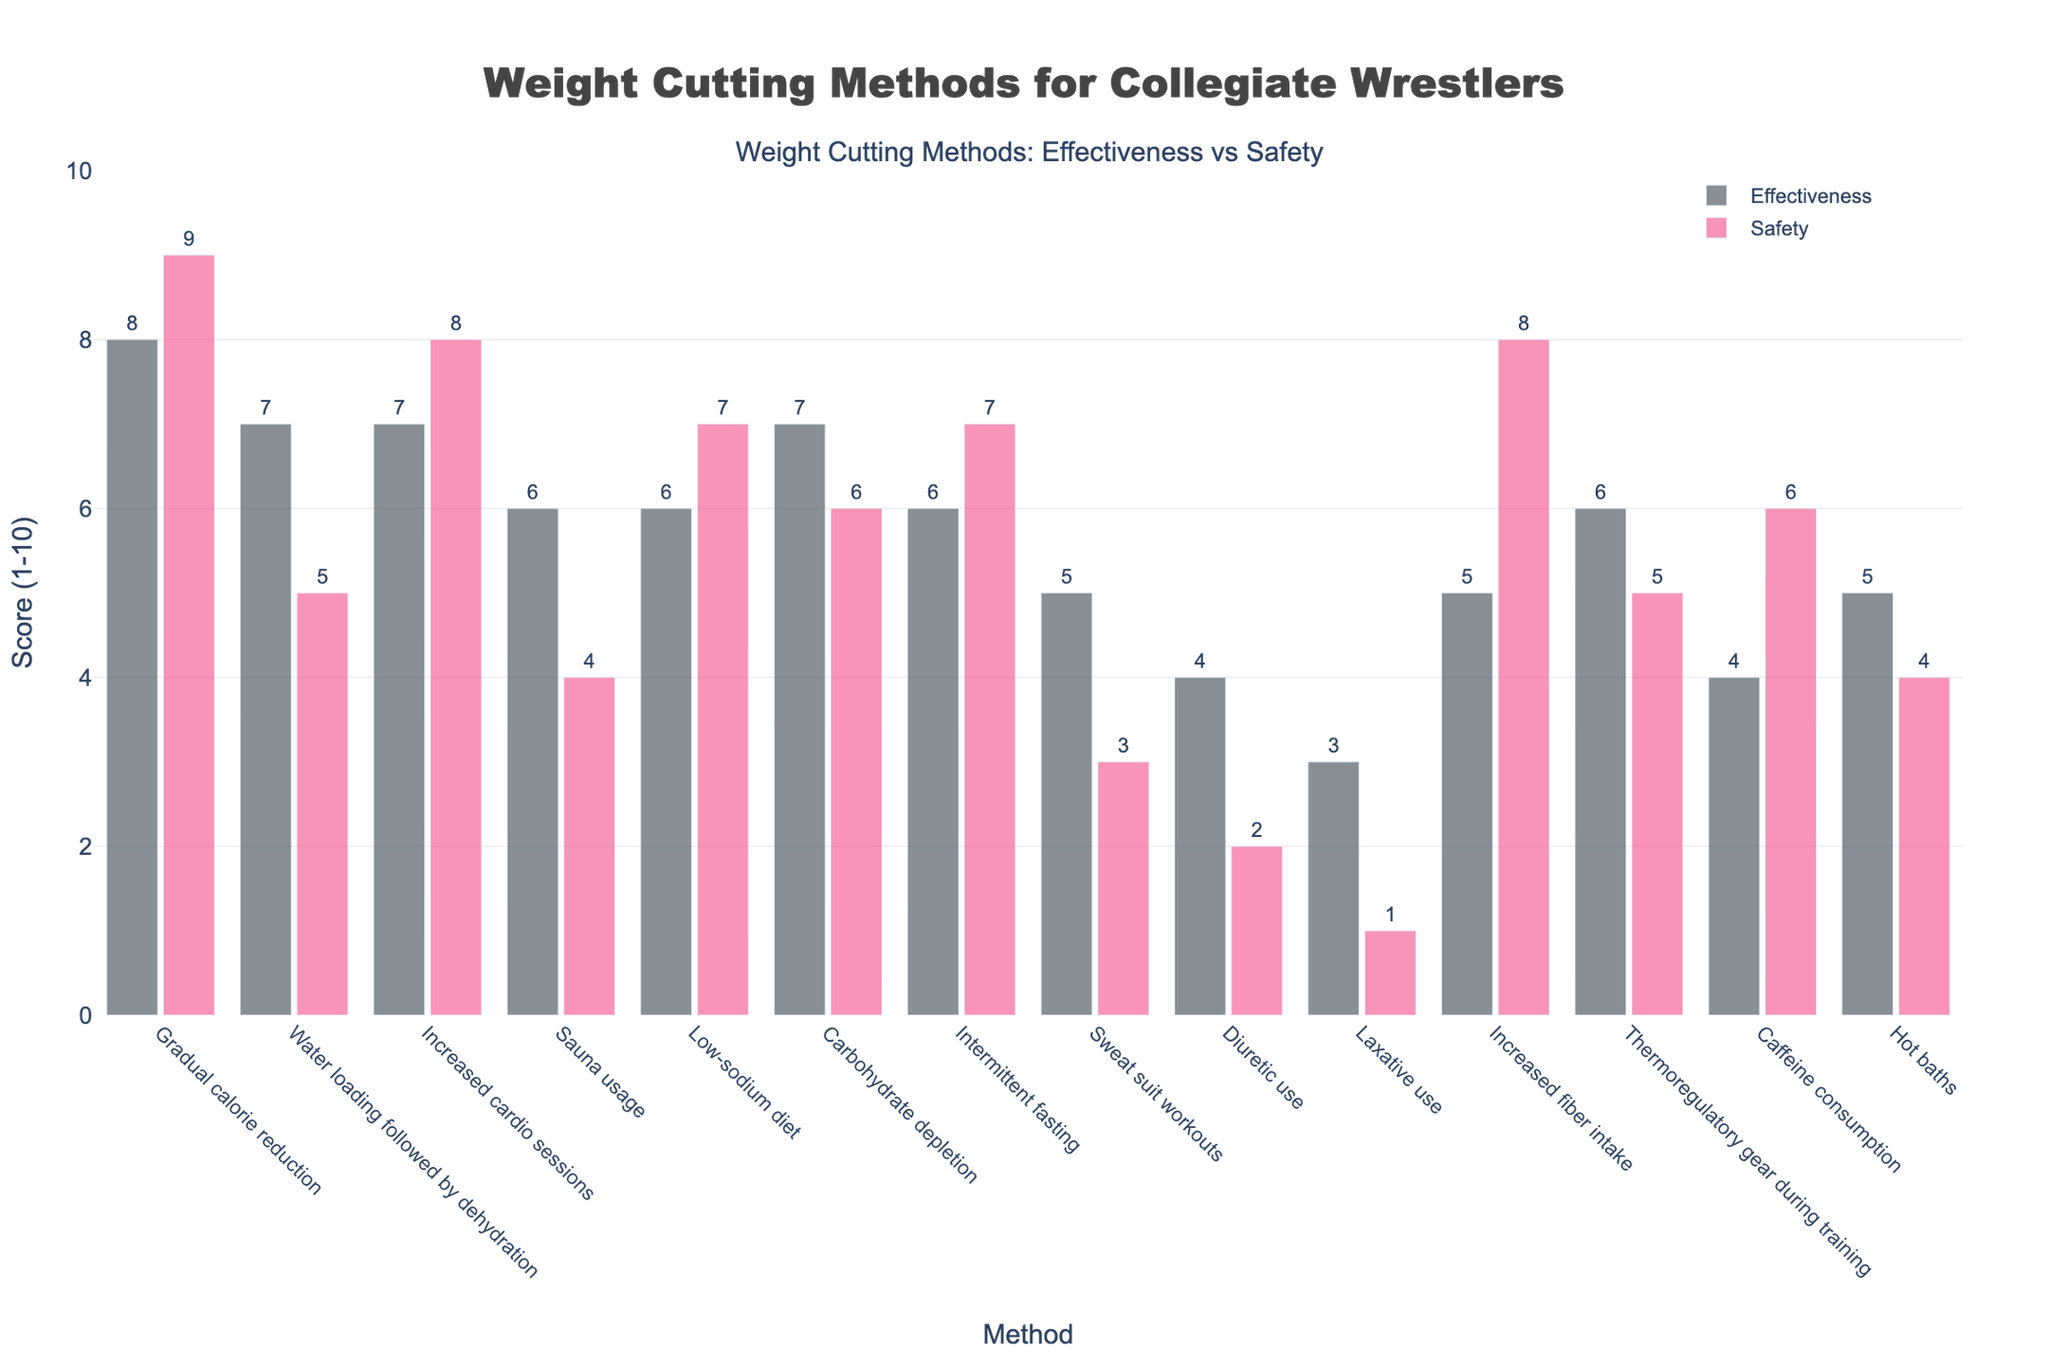What's the most effective weight cutting method based on the figure? The figure shows bars representing the effectiveness scores of various methods. The tallest bar for effectiveness is "Gradual calorie reduction" with a score of 8.
Answer: Gradual calorie reduction Which method is the least safe based on the figure? The figure shows bars representing the safety scores of various methods. The shortest bar for safety is "Laxative use" with a score of 1.
Answer: Laxative use Which methods have the exact same safety score, and what is that score? The figure shows bars for safety scores, and both "Low-sodium diet" and "Intermittent fasting" have bars reaching the same height of 7.
Answer: Low-sodium diet and Intermittent fasting; 7 What's the difference in safety scores between "Water loading followed by dehydration" and "Caffeine consumption"? The safety score for "Water loading followed by dehydration" is 5, and for "Caffeine consumption" it is 6. The difference is 6 - 5 = 1.
Answer: 1 Which methods have an effectiveness of 7, and how do their safety scores compare? The methods with an effectiveness score of 7 are "Water loading followed by dehydration," "Increased cardio sessions," and "Carbohydrate depletion." Their safety scores are 5, 8, and 6, respectively, with "Increased cardio sessions" being the safest.
Answer: Water loading followed by dehydration (5), Increased cardio sessions (8), Carbohydrate depletion (6) What's the average safety score of the top three most effective methods? The top three most effective methods are "Gradual calorie reduction" (8), "Water loading followed by dehydration" (7), and "Increased cardio sessions" (7). Their safety scores are 9, 5, and 8, respectively. The average safety score is (9 + 5 + 8) / 3 = 22 / 3 ≈ 7.33.
Answer: 7.33 Which method shows a large discrepancy between effectiveness and safety, and what are the respective scores? A large discrepancy is observed in "Sweat suit workouts," which has an effectiveness score of 5 and a safety score of 3, showing a difference of 2 points.
Answer: Sweat suit workouts; Effectiveness: 5, Safety: 3 Compare the safety scores of "Sauna usage" and "Hot baths." Which is safer? The safety score for "Sauna usage" is 4, and for "Hot baths" it is also 4. They are equally safe.
Answer: Sauna usage and Hot baths; equally safe What's the combined effectiveness score of "Diuretic use" and "Laxative use"? The effectiveness scores for "Diuretic use" and "Laxative use" are 4 and 3, respectively. The combined score is 4 + 3 = 7.
Answer: 7 Which two methods tied in effectiveness and what is their score? The methods "Sauna usage" and "Low-sodium diet" both have an effectiveness score of 6.
Answer: Sauna usage and Low-sodium diet; 6 